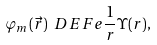Convert formula to latex. <formula><loc_0><loc_0><loc_500><loc_500>\varphi _ { m } ( \vec { r } ) \ D E F e \frac { 1 } { r } \Upsilon ( r ) ,</formula> 